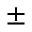<formula> <loc_0><loc_0><loc_500><loc_500>\pm</formula> 